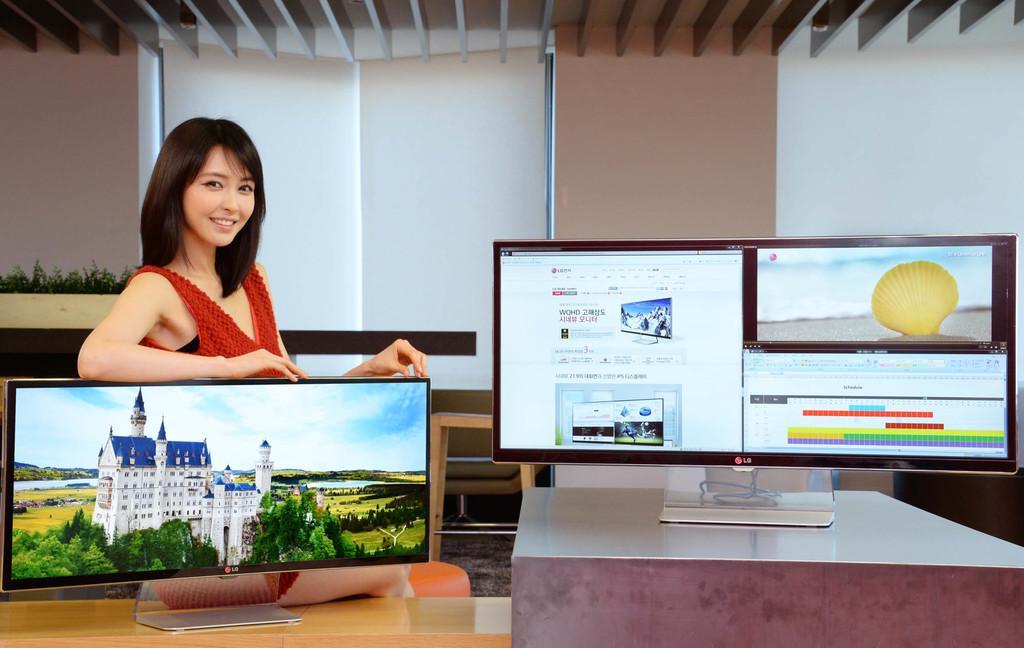How would you summarize this image in a sentence or two? there are 2 screens. behind the left screen a person is standing. behind her there is a wall. 